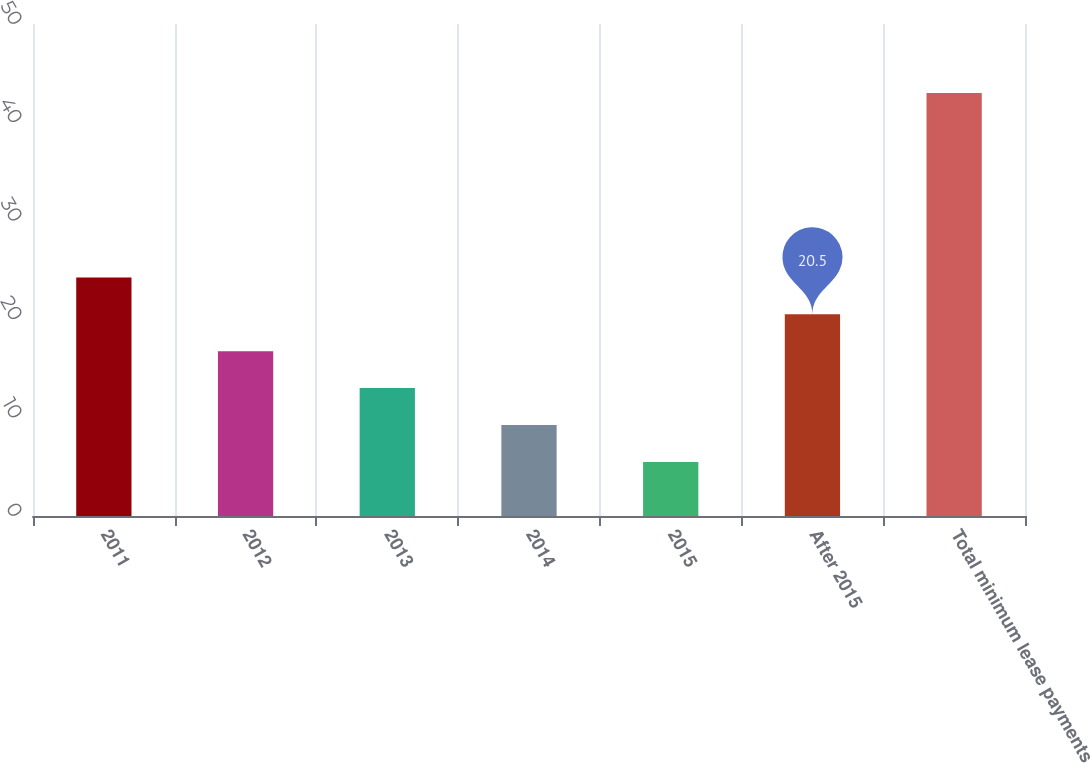<chart> <loc_0><loc_0><loc_500><loc_500><bar_chart><fcel>2011<fcel>2012<fcel>2013<fcel>2014<fcel>2015<fcel>After 2015<fcel>Total minimum lease payments<nl><fcel>24.25<fcel>16.75<fcel>13<fcel>9.25<fcel>5.5<fcel>20.5<fcel>43<nl></chart> 